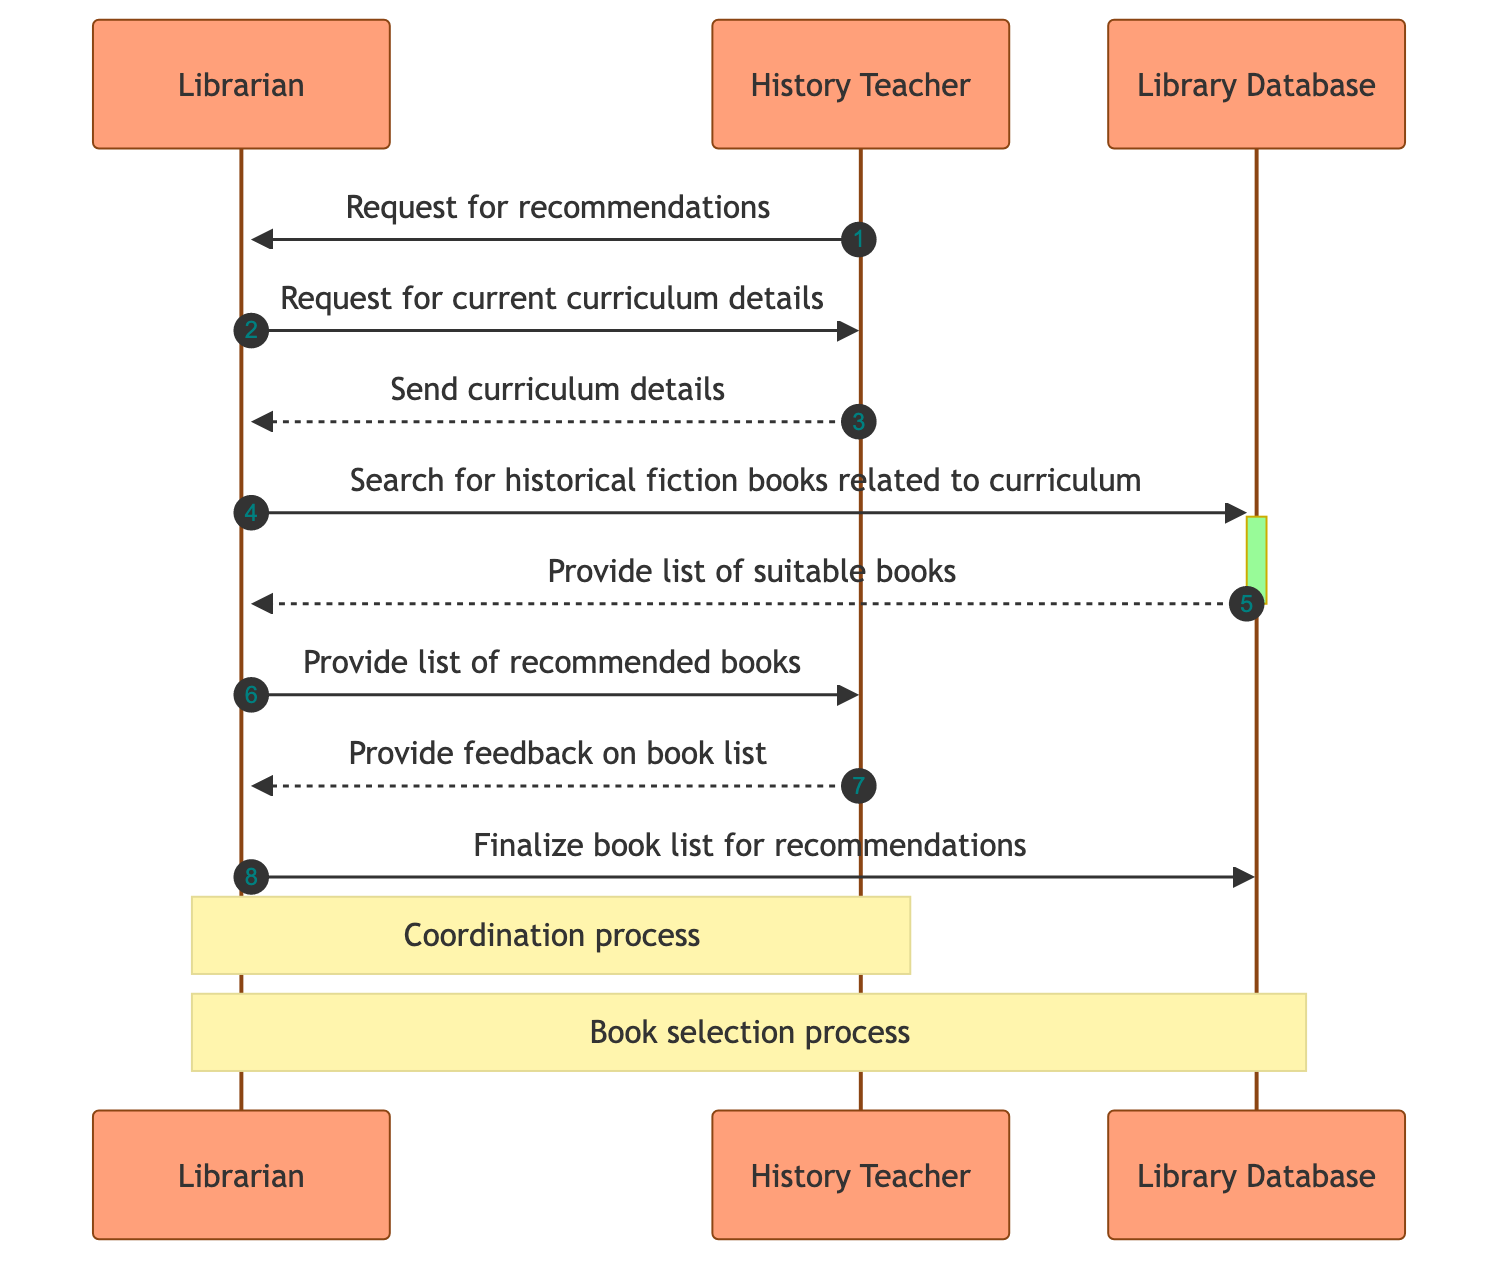What is the first action taken in the sequence? The first action is initiated by the History Teacher who sends a "Request for recommendations" to the Librarian. This is the starting point of the interaction depicted in the diagram.
Answer: Request for recommendations How many participants are involved in the sequence? The diagram features two main participants: the Librarian and the History Teacher. Additionally, the Library Database is included as a third entity that the Librarian interacts with.
Answer: Three Which participant sends the final message in the sequence? The final message is sent by the Librarian to the Library Database, which corresponds to the action of finalizing the book list for recommendations. This indicates the end of the sequence's primary interactions from the Librarian's perspective.
Answer: Librarian What type of information does the Librarian request from the History Teacher? The Librarian requests "current curriculum details," which helps in narrowing down the types of book recommendations that can be provided relevant to the teaching curriculum. This step is crucial as it enables informed sourcing of appropriate historical fiction books.
Answer: Current curriculum details Which action occurs immediately after the Librarian searches for books in the Library Database? After the Librarian searches for historical fiction books related to the curriculum, the Library Database responds by providing a "list of suitable books". This process connects the search action directly to obtaining relevant recommendations.
Answer: Provide list of suitable books What feedback does the History Teacher give after receiving the book list? The History Teacher provides feedback on the book list that has been presented by the Librarian. This feedback step is important as it helps refine the recommendations offered based on the teacher's preferences or needs.
Answer: Provide feedback on book list How many messages are exchanged between the History Teacher and the Librarian? The total number of messages exchanged between the History Teacher and the Librarian is four. This includes the initial request for recommendations, the request for curriculum details, the provision of feedback, and the delivery of the recommended books.
Answer: Four What is the purpose of the final step taken by the Librarian? The final step taken by the Librarian in the sequence is to "Finalize book list for recommendations". This action ensures that the selected book list is confirmed and ready for sharing or further use in the classroom context.
Answer: Finalize book list for recommendations 